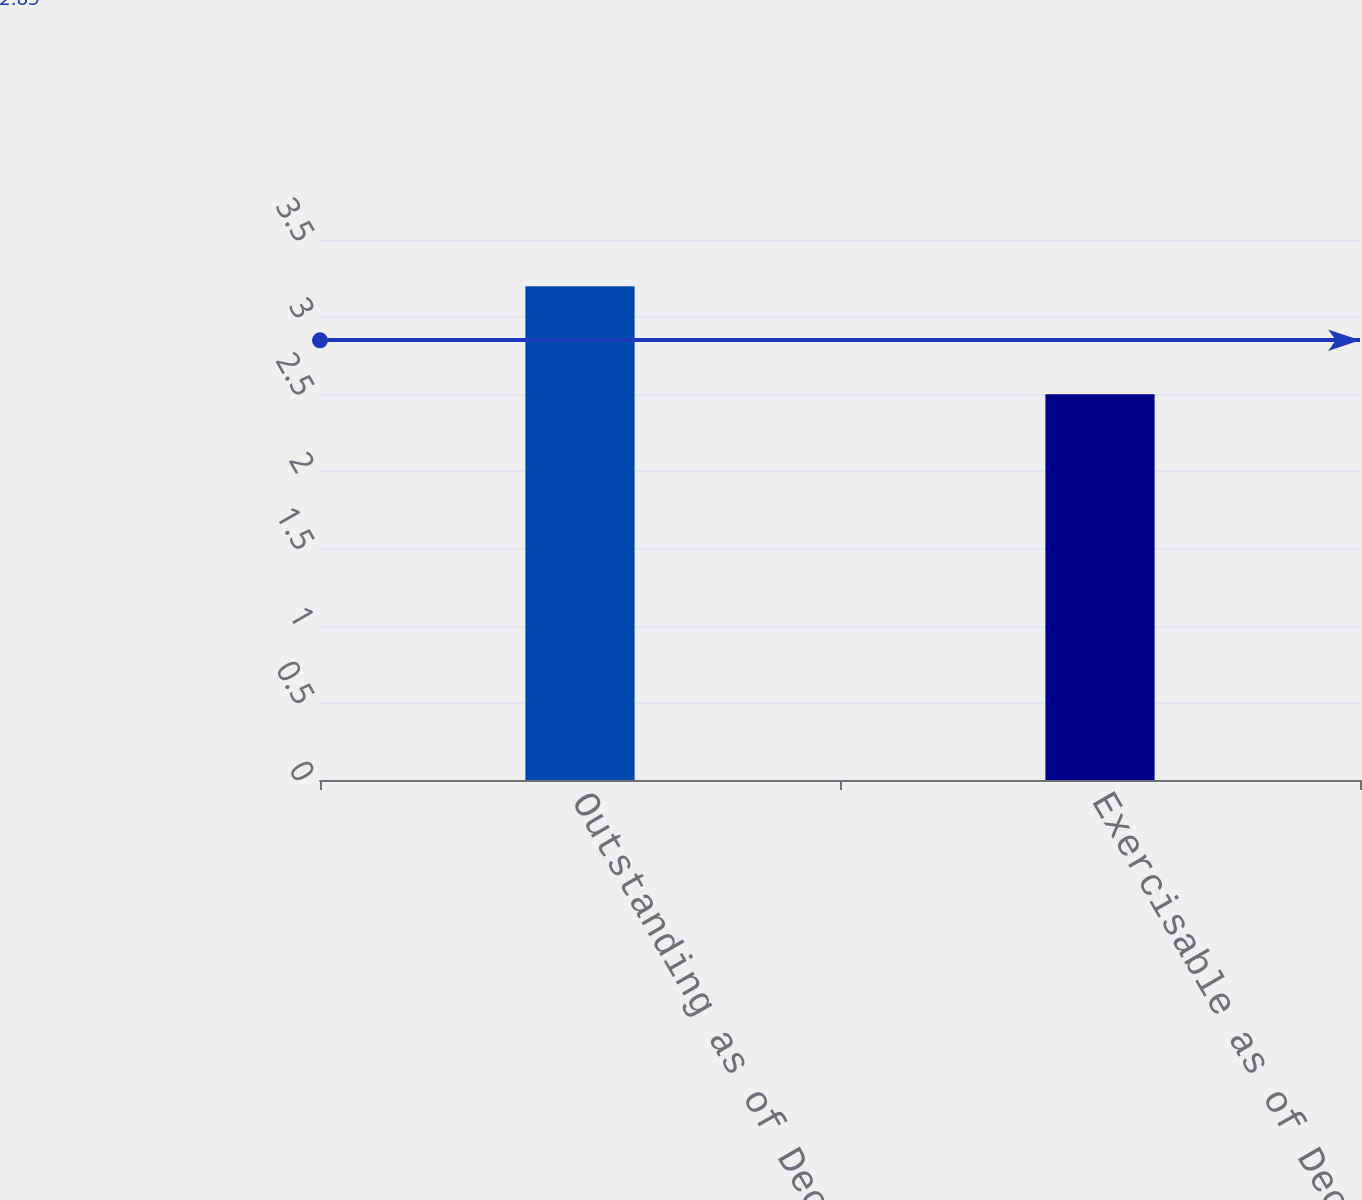Convert chart to OTSL. <chart><loc_0><loc_0><loc_500><loc_500><bar_chart><fcel>Outstanding as of December 31<fcel>Exercisable as of December 31<nl><fcel>3.2<fcel>2.5<nl></chart> 